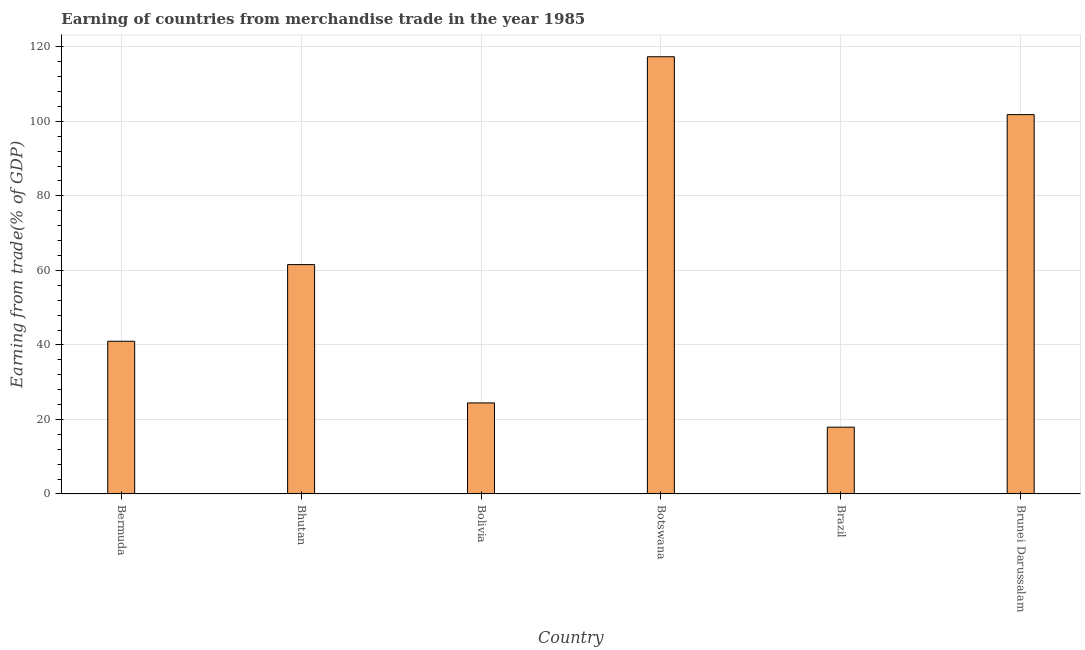Does the graph contain any zero values?
Provide a short and direct response. No. Does the graph contain grids?
Provide a succinct answer. Yes. What is the title of the graph?
Your answer should be compact. Earning of countries from merchandise trade in the year 1985. What is the label or title of the X-axis?
Your response must be concise. Country. What is the label or title of the Y-axis?
Keep it short and to the point. Earning from trade(% of GDP). What is the earning from merchandise trade in Bermuda?
Your answer should be very brief. 40.98. Across all countries, what is the maximum earning from merchandise trade?
Your answer should be compact. 117.33. Across all countries, what is the minimum earning from merchandise trade?
Your answer should be very brief. 17.93. In which country was the earning from merchandise trade maximum?
Your answer should be compact. Botswana. What is the sum of the earning from merchandise trade?
Offer a very short reply. 364.03. What is the difference between the earning from merchandise trade in Bolivia and Brazil?
Provide a succinct answer. 6.51. What is the average earning from merchandise trade per country?
Offer a very short reply. 60.67. What is the median earning from merchandise trade?
Make the answer very short. 51.27. In how many countries, is the earning from merchandise trade greater than 32 %?
Provide a succinct answer. 4. What is the ratio of the earning from merchandise trade in Botswana to that in Brazil?
Provide a short and direct response. 6.54. Is the earning from merchandise trade in Bermuda less than that in Botswana?
Offer a terse response. Yes. What is the difference between the highest and the second highest earning from merchandise trade?
Give a very brief answer. 15.53. What is the difference between the highest and the lowest earning from merchandise trade?
Provide a succinct answer. 99.4. In how many countries, is the earning from merchandise trade greater than the average earning from merchandise trade taken over all countries?
Offer a very short reply. 3. How many bars are there?
Offer a terse response. 6. Are all the bars in the graph horizontal?
Your response must be concise. No. How many countries are there in the graph?
Ensure brevity in your answer.  6. What is the Earning from trade(% of GDP) in Bermuda?
Provide a succinct answer. 40.98. What is the Earning from trade(% of GDP) of Bhutan?
Offer a very short reply. 61.55. What is the Earning from trade(% of GDP) of Bolivia?
Offer a terse response. 24.44. What is the Earning from trade(% of GDP) of Botswana?
Keep it short and to the point. 117.33. What is the Earning from trade(% of GDP) of Brazil?
Your answer should be very brief. 17.93. What is the Earning from trade(% of GDP) in Brunei Darussalam?
Give a very brief answer. 101.8. What is the difference between the Earning from trade(% of GDP) in Bermuda and Bhutan?
Keep it short and to the point. -20.57. What is the difference between the Earning from trade(% of GDP) in Bermuda and Bolivia?
Offer a terse response. 16.55. What is the difference between the Earning from trade(% of GDP) in Bermuda and Botswana?
Offer a very short reply. -76.35. What is the difference between the Earning from trade(% of GDP) in Bermuda and Brazil?
Your answer should be very brief. 23.05. What is the difference between the Earning from trade(% of GDP) in Bermuda and Brunei Darussalam?
Your answer should be compact. -60.82. What is the difference between the Earning from trade(% of GDP) in Bhutan and Bolivia?
Your answer should be compact. 37.11. What is the difference between the Earning from trade(% of GDP) in Bhutan and Botswana?
Offer a terse response. -55.78. What is the difference between the Earning from trade(% of GDP) in Bhutan and Brazil?
Keep it short and to the point. 43.62. What is the difference between the Earning from trade(% of GDP) in Bhutan and Brunei Darussalam?
Ensure brevity in your answer.  -40.25. What is the difference between the Earning from trade(% of GDP) in Bolivia and Botswana?
Ensure brevity in your answer.  -92.9. What is the difference between the Earning from trade(% of GDP) in Bolivia and Brazil?
Your response must be concise. 6.51. What is the difference between the Earning from trade(% of GDP) in Bolivia and Brunei Darussalam?
Your answer should be very brief. -77.36. What is the difference between the Earning from trade(% of GDP) in Botswana and Brazil?
Ensure brevity in your answer.  99.4. What is the difference between the Earning from trade(% of GDP) in Botswana and Brunei Darussalam?
Your response must be concise. 15.53. What is the difference between the Earning from trade(% of GDP) in Brazil and Brunei Darussalam?
Provide a succinct answer. -83.87. What is the ratio of the Earning from trade(% of GDP) in Bermuda to that in Bhutan?
Provide a succinct answer. 0.67. What is the ratio of the Earning from trade(% of GDP) in Bermuda to that in Bolivia?
Ensure brevity in your answer.  1.68. What is the ratio of the Earning from trade(% of GDP) in Bermuda to that in Botswana?
Your response must be concise. 0.35. What is the ratio of the Earning from trade(% of GDP) in Bermuda to that in Brazil?
Ensure brevity in your answer.  2.29. What is the ratio of the Earning from trade(% of GDP) in Bermuda to that in Brunei Darussalam?
Ensure brevity in your answer.  0.4. What is the ratio of the Earning from trade(% of GDP) in Bhutan to that in Bolivia?
Your response must be concise. 2.52. What is the ratio of the Earning from trade(% of GDP) in Bhutan to that in Botswana?
Your response must be concise. 0.53. What is the ratio of the Earning from trade(% of GDP) in Bhutan to that in Brazil?
Give a very brief answer. 3.43. What is the ratio of the Earning from trade(% of GDP) in Bhutan to that in Brunei Darussalam?
Offer a very short reply. 0.6. What is the ratio of the Earning from trade(% of GDP) in Bolivia to that in Botswana?
Offer a terse response. 0.21. What is the ratio of the Earning from trade(% of GDP) in Bolivia to that in Brazil?
Provide a succinct answer. 1.36. What is the ratio of the Earning from trade(% of GDP) in Bolivia to that in Brunei Darussalam?
Provide a short and direct response. 0.24. What is the ratio of the Earning from trade(% of GDP) in Botswana to that in Brazil?
Offer a terse response. 6.54. What is the ratio of the Earning from trade(% of GDP) in Botswana to that in Brunei Darussalam?
Provide a succinct answer. 1.15. What is the ratio of the Earning from trade(% of GDP) in Brazil to that in Brunei Darussalam?
Give a very brief answer. 0.18. 